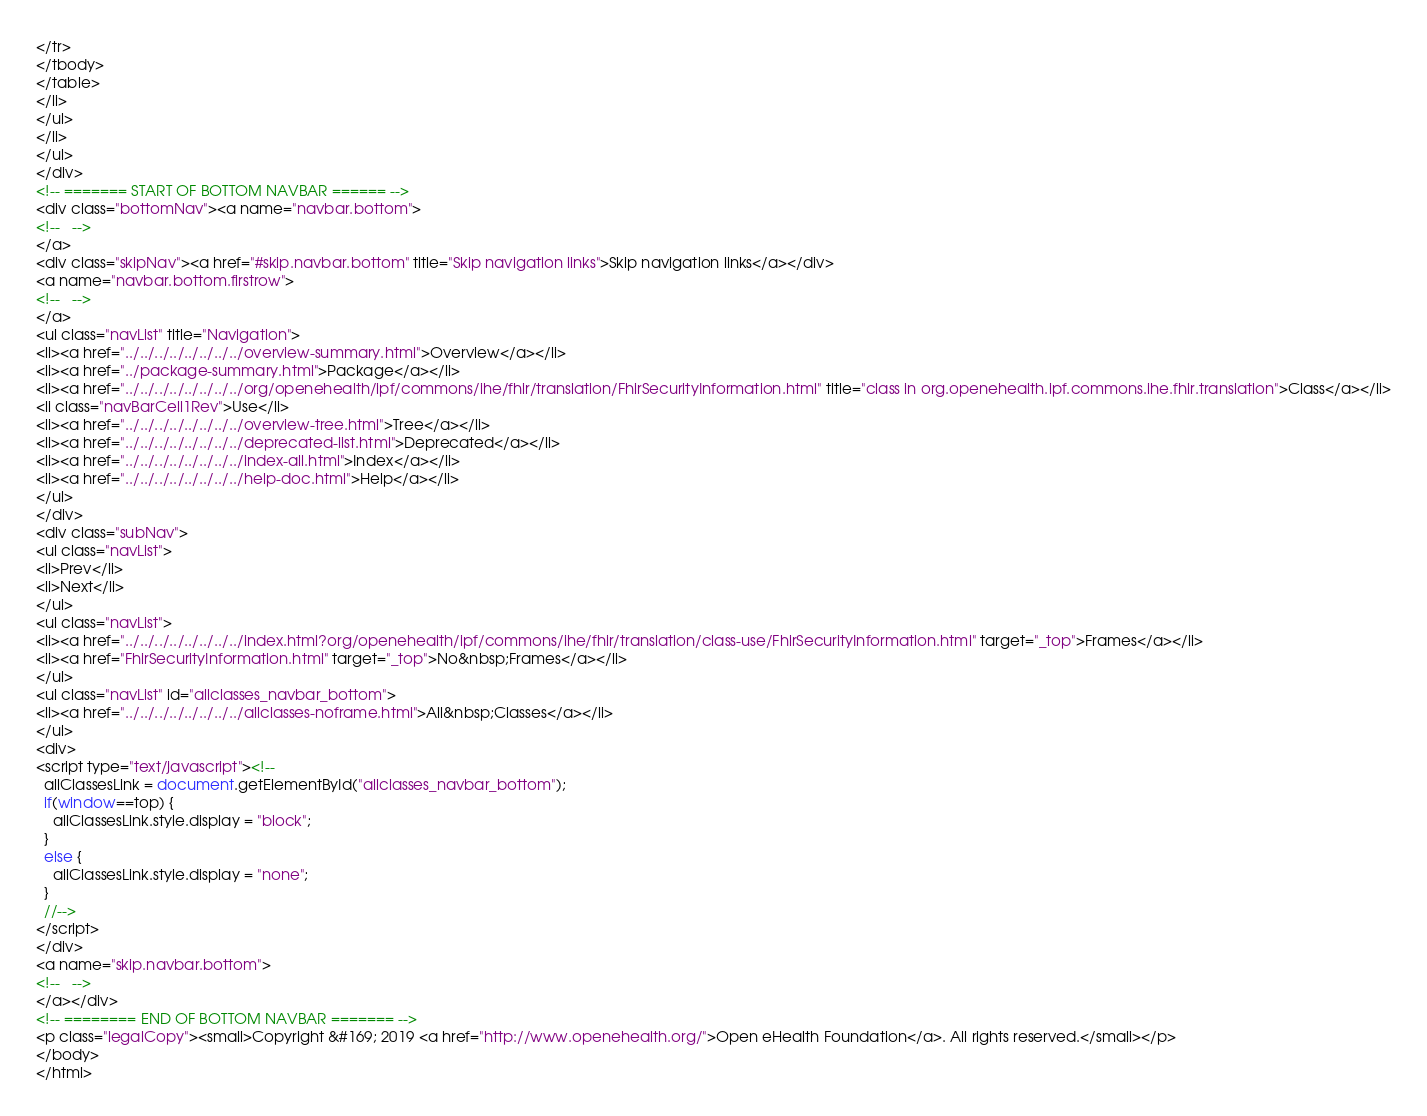<code> <loc_0><loc_0><loc_500><loc_500><_HTML_></tr>
</tbody>
</table>
</li>
</ul>
</li>
</ul>
</div>
<!-- ======= START OF BOTTOM NAVBAR ====== -->
<div class="bottomNav"><a name="navbar.bottom">
<!--   -->
</a>
<div class="skipNav"><a href="#skip.navbar.bottom" title="Skip navigation links">Skip navigation links</a></div>
<a name="navbar.bottom.firstrow">
<!--   -->
</a>
<ul class="navList" title="Navigation">
<li><a href="../../../../../../../../overview-summary.html">Overview</a></li>
<li><a href="../package-summary.html">Package</a></li>
<li><a href="../../../../../../../../org/openehealth/ipf/commons/ihe/fhir/translation/FhirSecurityInformation.html" title="class in org.openehealth.ipf.commons.ihe.fhir.translation">Class</a></li>
<li class="navBarCell1Rev">Use</li>
<li><a href="../../../../../../../../overview-tree.html">Tree</a></li>
<li><a href="../../../../../../../../deprecated-list.html">Deprecated</a></li>
<li><a href="../../../../../../../../index-all.html">Index</a></li>
<li><a href="../../../../../../../../help-doc.html">Help</a></li>
</ul>
</div>
<div class="subNav">
<ul class="navList">
<li>Prev</li>
<li>Next</li>
</ul>
<ul class="navList">
<li><a href="../../../../../../../../index.html?org/openehealth/ipf/commons/ihe/fhir/translation/class-use/FhirSecurityInformation.html" target="_top">Frames</a></li>
<li><a href="FhirSecurityInformation.html" target="_top">No&nbsp;Frames</a></li>
</ul>
<ul class="navList" id="allclasses_navbar_bottom">
<li><a href="../../../../../../../../allclasses-noframe.html">All&nbsp;Classes</a></li>
</ul>
<div>
<script type="text/javascript"><!--
  allClassesLink = document.getElementById("allclasses_navbar_bottom");
  if(window==top) {
    allClassesLink.style.display = "block";
  }
  else {
    allClassesLink.style.display = "none";
  }
  //-->
</script>
</div>
<a name="skip.navbar.bottom">
<!--   -->
</a></div>
<!-- ======== END OF BOTTOM NAVBAR ======= -->
<p class="legalCopy"><small>Copyright &#169; 2019 <a href="http://www.openehealth.org/">Open eHealth Foundation</a>. All rights reserved.</small></p>
</body>
</html>
</code> 